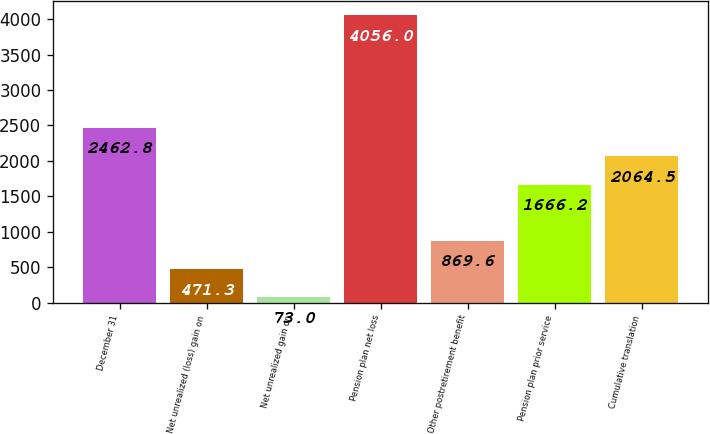Convert chart to OTSL. <chart><loc_0><loc_0><loc_500><loc_500><bar_chart><fcel>December 31<fcel>Net unrealized (loss) gain on<fcel>Net unrealized gain on<fcel>Pension plan net loss<fcel>Other postretirement benefit<fcel>Pension plan prior service<fcel>Cumulative translation<nl><fcel>2462.8<fcel>471.3<fcel>73<fcel>4056<fcel>869.6<fcel>1666.2<fcel>2064.5<nl></chart> 